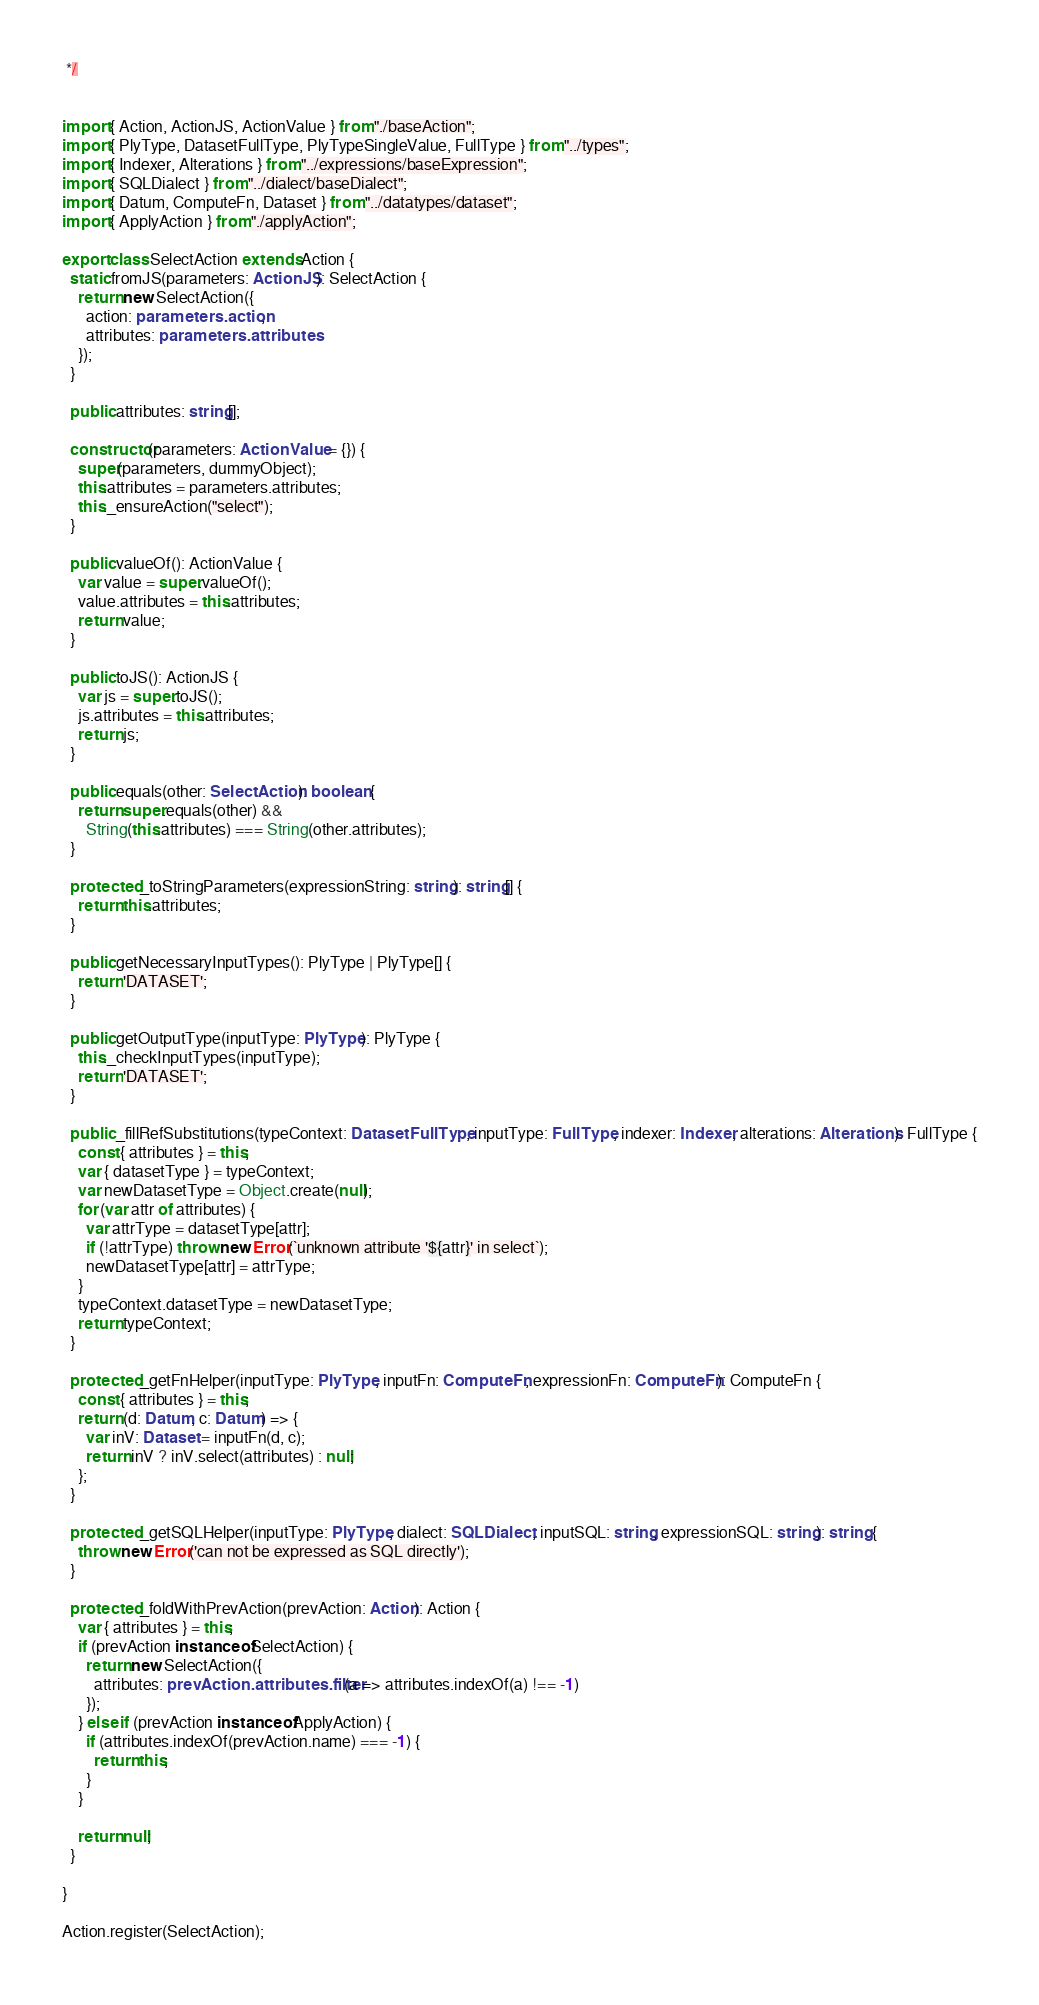Convert code to text. <code><loc_0><loc_0><loc_500><loc_500><_TypeScript_> */


import { Action, ActionJS, ActionValue } from "./baseAction";
import { PlyType, DatasetFullType, PlyTypeSingleValue, FullType } from "../types";
import { Indexer, Alterations } from "../expressions/baseExpression";
import { SQLDialect } from "../dialect/baseDialect";
import { Datum, ComputeFn, Dataset } from "../datatypes/dataset";
import { ApplyAction } from "./applyAction";

export class SelectAction extends Action {
  static fromJS(parameters: ActionJS): SelectAction {
    return new SelectAction({
      action: parameters.action,
      attributes: parameters.attributes
    });
  }

  public attributes: string[];

  constructor(parameters: ActionValue = {}) {
    super(parameters, dummyObject);
    this.attributes = parameters.attributes;
    this._ensureAction("select");
  }

  public valueOf(): ActionValue {
    var value = super.valueOf();
    value.attributes = this.attributes;
    return value;
  }

  public toJS(): ActionJS {
    var js = super.toJS();
    js.attributes = this.attributes;
    return js;
  }

  public equals(other: SelectAction): boolean {
    return super.equals(other) &&
      String(this.attributes) === String(other.attributes);
  }

  protected _toStringParameters(expressionString: string): string[] {
    return this.attributes;
  }

  public getNecessaryInputTypes(): PlyType | PlyType[] {
    return 'DATASET';
  }

  public getOutputType(inputType: PlyType): PlyType {
    this._checkInputTypes(inputType);
    return 'DATASET';
  }

  public _fillRefSubstitutions(typeContext: DatasetFullType, inputType: FullType, indexer: Indexer, alterations: Alterations): FullType {
    const { attributes } = this;
    var { datasetType } = typeContext;
    var newDatasetType = Object.create(null);
    for (var attr of attributes) {
      var attrType = datasetType[attr];
      if (!attrType) throw new Error(`unknown attribute '${attr}' in select`);
      newDatasetType[attr] = attrType;
    }
    typeContext.datasetType = newDatasetType;
    return typeContext;
  }

  protected _getFnHelper(inputType: PlyType, inputFn: ComputeFn, expressionFn: ComputeFn): ComputeFn {
    const { attributes } = this;
    return (d: Datum, c: Datum) => {
      var inV: Dataset = inputFn(d, c);
      return inV ? inV.select(attributes) : null;
    };
  }

  protected _getSQLHelper(inputType: PlyType, dialect: SQLDialect, inputSQL: string, expressionSQL: string): string {
    throw new Error('can not be expressed as SQL directly');
  }

  protected _foldWithPrevAction(prevAction: Action): Action {
    var { attributes } = this;
    if (prevAction instanceof SelectAction) {
      return new SelectAction({
        attributes: prevAction.attributes.filter(a => attributes.indexOf(a) !== -1)
      });
    } else if (prevAction instanceof ApplyAction) {
      if (attributes.indexOf(prevAction.name) === -1) {
        return this;
      }
    }

    return null;
  }

}

Action.register(SelectAction);
</code> 